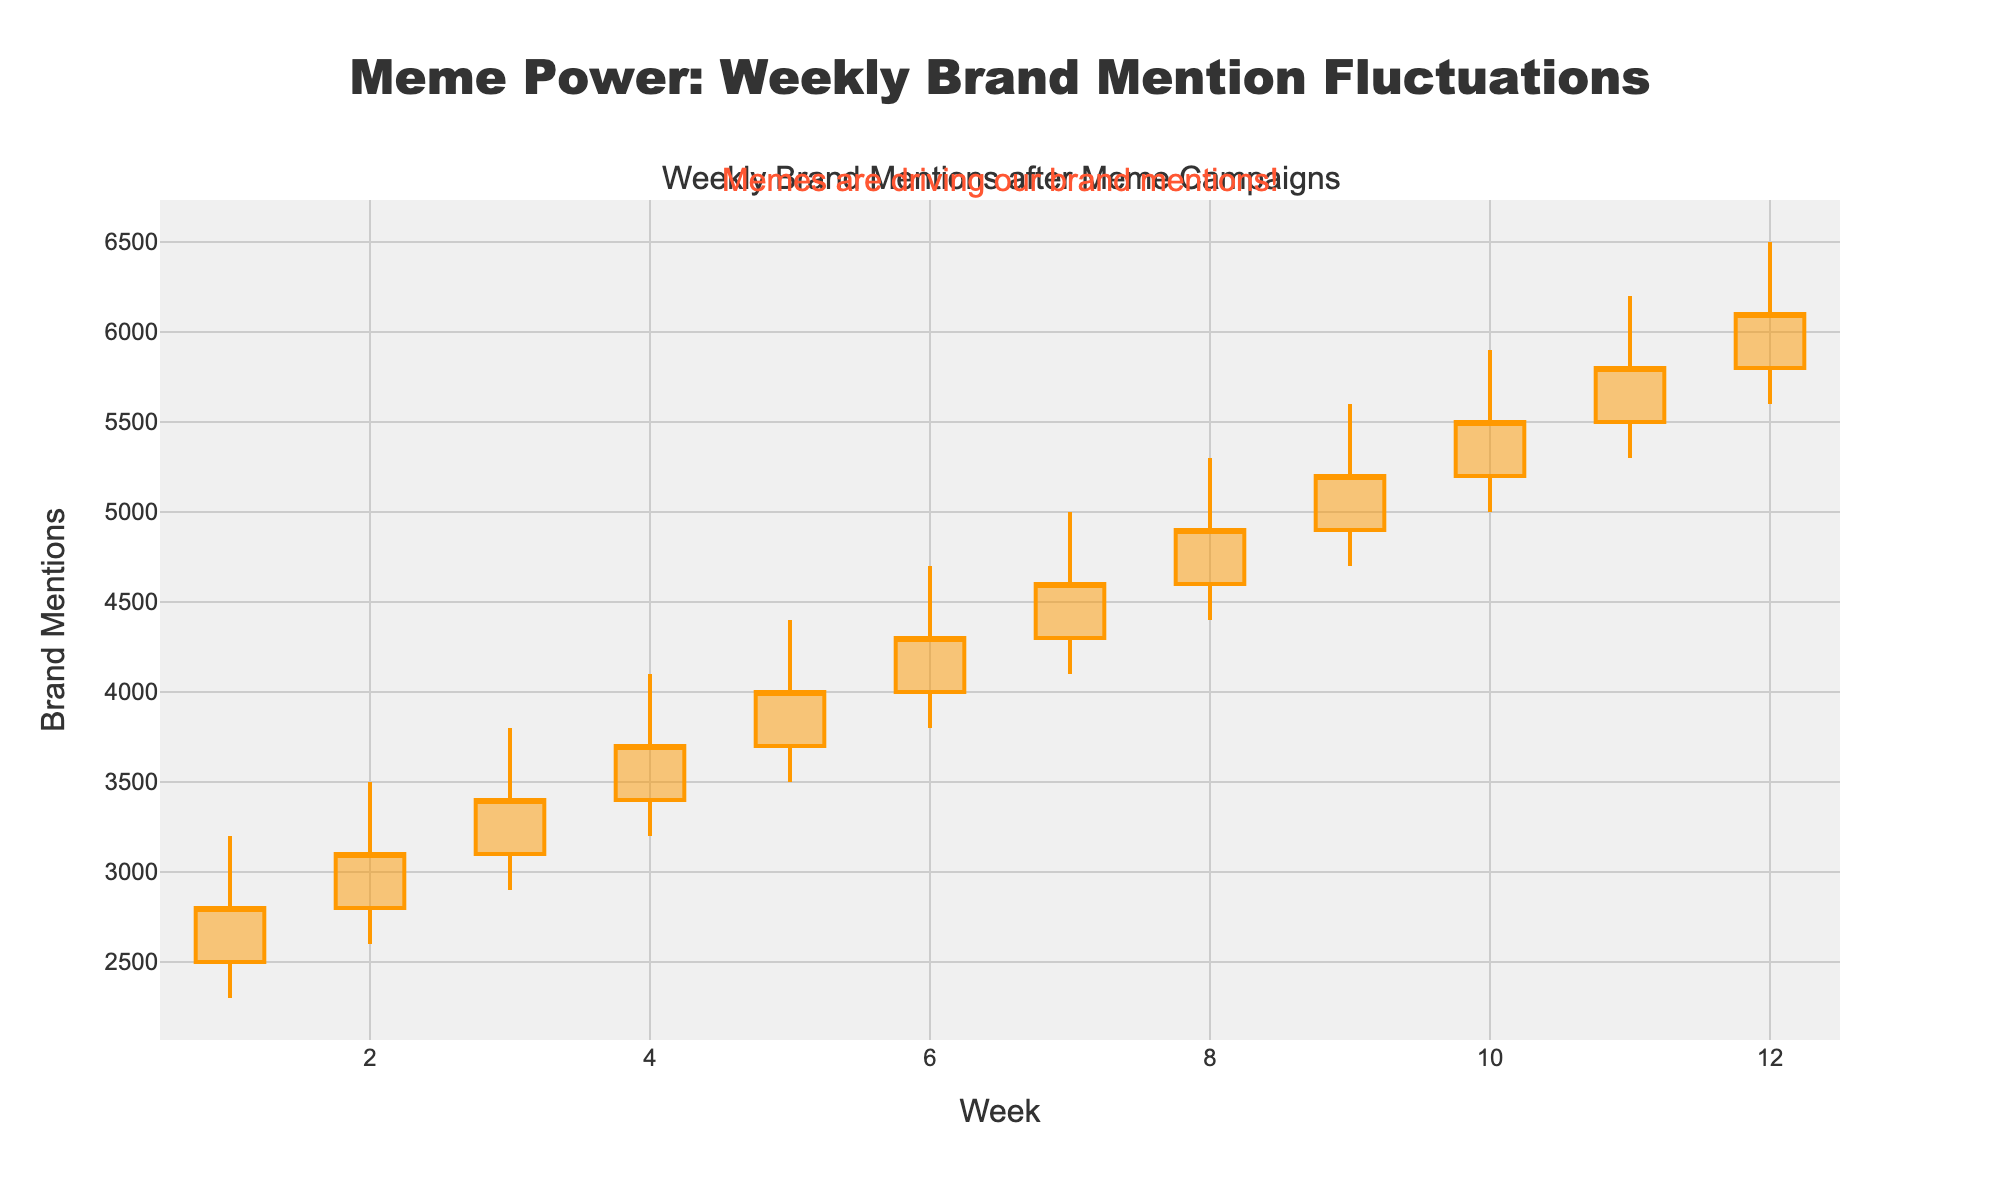What's the general title of the plot? The title of the plot is located at the top of the figure. Reading from the chart, the title is "Meme Power: Weekly Brand Mention Fluctuations".
Answer: Meme Power: Weekly Brand Mention Fluctuations How many weeks does the plot cover? The x-axis represents the weeks, and its range spans from Week 1 to Week 12. By counting these intervals, you can determine that the plot covers 12 weeks.
Answer: 12 What is the maximum high value recorded, and in which week did it occur? The highest value is where the highest point of the candlestick reaches. Observing the chart, the maximum high value recorded is 6500, which is seen in Week 12.
Answer: 6500 in Week 12 What is the trend of the closing values over the 12 weeks? Observing the closing values for each week, it is evident that they generally increase over time. The closing value starts at 2800 in Week 1 and rises steadily to 6100 by Week 12.
Answer: Generally increasing What is the range (difference between the high and low) for Week 6? The range can be calculated by subtracting the low value from the high value for Week 6. The high is 4700, and the low is 3800. Thus, the range is 4700 - 3800 = 900.
Answer: 900 Which week had the lowest closing value, and what was that value? The lowest closing value can be found at the bottom of each candlestick. Observing the figure, the lowest closing value is 2800, which occurs in Week 1.
Answer: Week 1, 2800 How many times does the closing value exceed 5000? To find this, identify how many candlesticks have their closing values positioned above 5000. From the figure, this occurs in Weeks 9, 10, 11, and 12, thus happening 4 times in total.
Answer: 4 Between which two consecutive weeks did the largest increase in closing value occur, and what was the increase? Analyzing the week-to-week changes in the closing values, the largest increase occurs between Week 2 and Week 3. The closing value jumps from 3100 to 3400, an increase of 300.
Answer: Between Week 2 and Week 3, 300 Which week experienced the greatest fluctuation (difference between high and low)? The greatest fluctuation is determined by the largest range (difference between high and low) for any week. In Week 12, the high is 6500, and the low is 5600, giving a fluctuation of 900, which is greater than any other week.
Answer: Week 12 What annotation is added to the chart, and what does it convey? The chart has an annotation at the top right reading "Memes are driving our brand mentions!". This conveys that meme-based marketing campaigns are significantly affecting the number of brand mentions.
Answer: Memes are driving our brand mentions! 